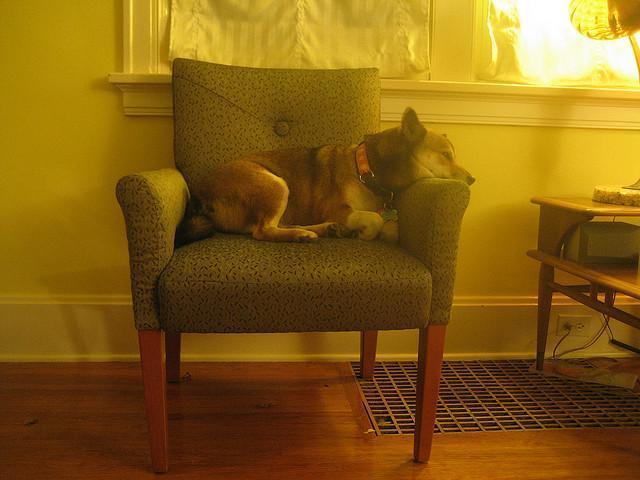How many electrical outlets are visible?
Give a very brief answer. 1. 